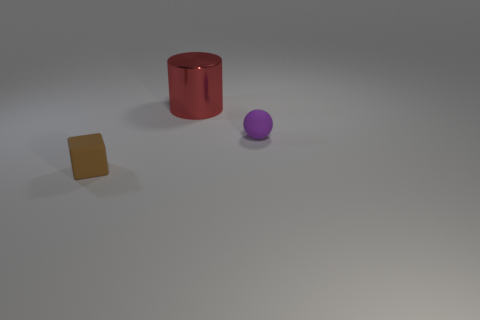What is the material of the cylinder?
Your answer should be very brief. Metal. How many objects are tiny purple cylinders or small matte objects?
Provide a succinct answer. 2. There is a object that is in front of the small purple ball; does it have the same size as the rubber object that is on the right side of the red metal cylinder?
Keep it short and to the point. Yes. What number of other things are the same size as the red object?
Keep it short and to the point. 0. How many objects are things left of the large cylinder or small objects that are to the right of the small block?
Your answer should be compact. 2. Is the material of the cube the same as the cylinder that is left of the purple ball?
Offer a very short reply. No. What number of other things are the same shape as the small purple object?
Make the answer very short. 0. The red object behind the matte thing that is in front of the tiny rubber thing on the right side of the small brown cube is made of what material?
Give a very brief answer. Metal. Is the number of shiny things that are to the left of the small brown rubber object the same as the number of big red cylinders?
Your answer should be compact. No. Is the material of the tiny ball that is in front of the red metal thing the same as the small thing left of the purple object?
Your answer should be very brief. Yes. 